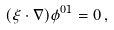Convert formula to latex. <formula><loc_0><loc_0><loc_500><loc_500>( \xi \cdot \nabla ) \phi ^ { 0 1 } = 0 \, ,</formula> 